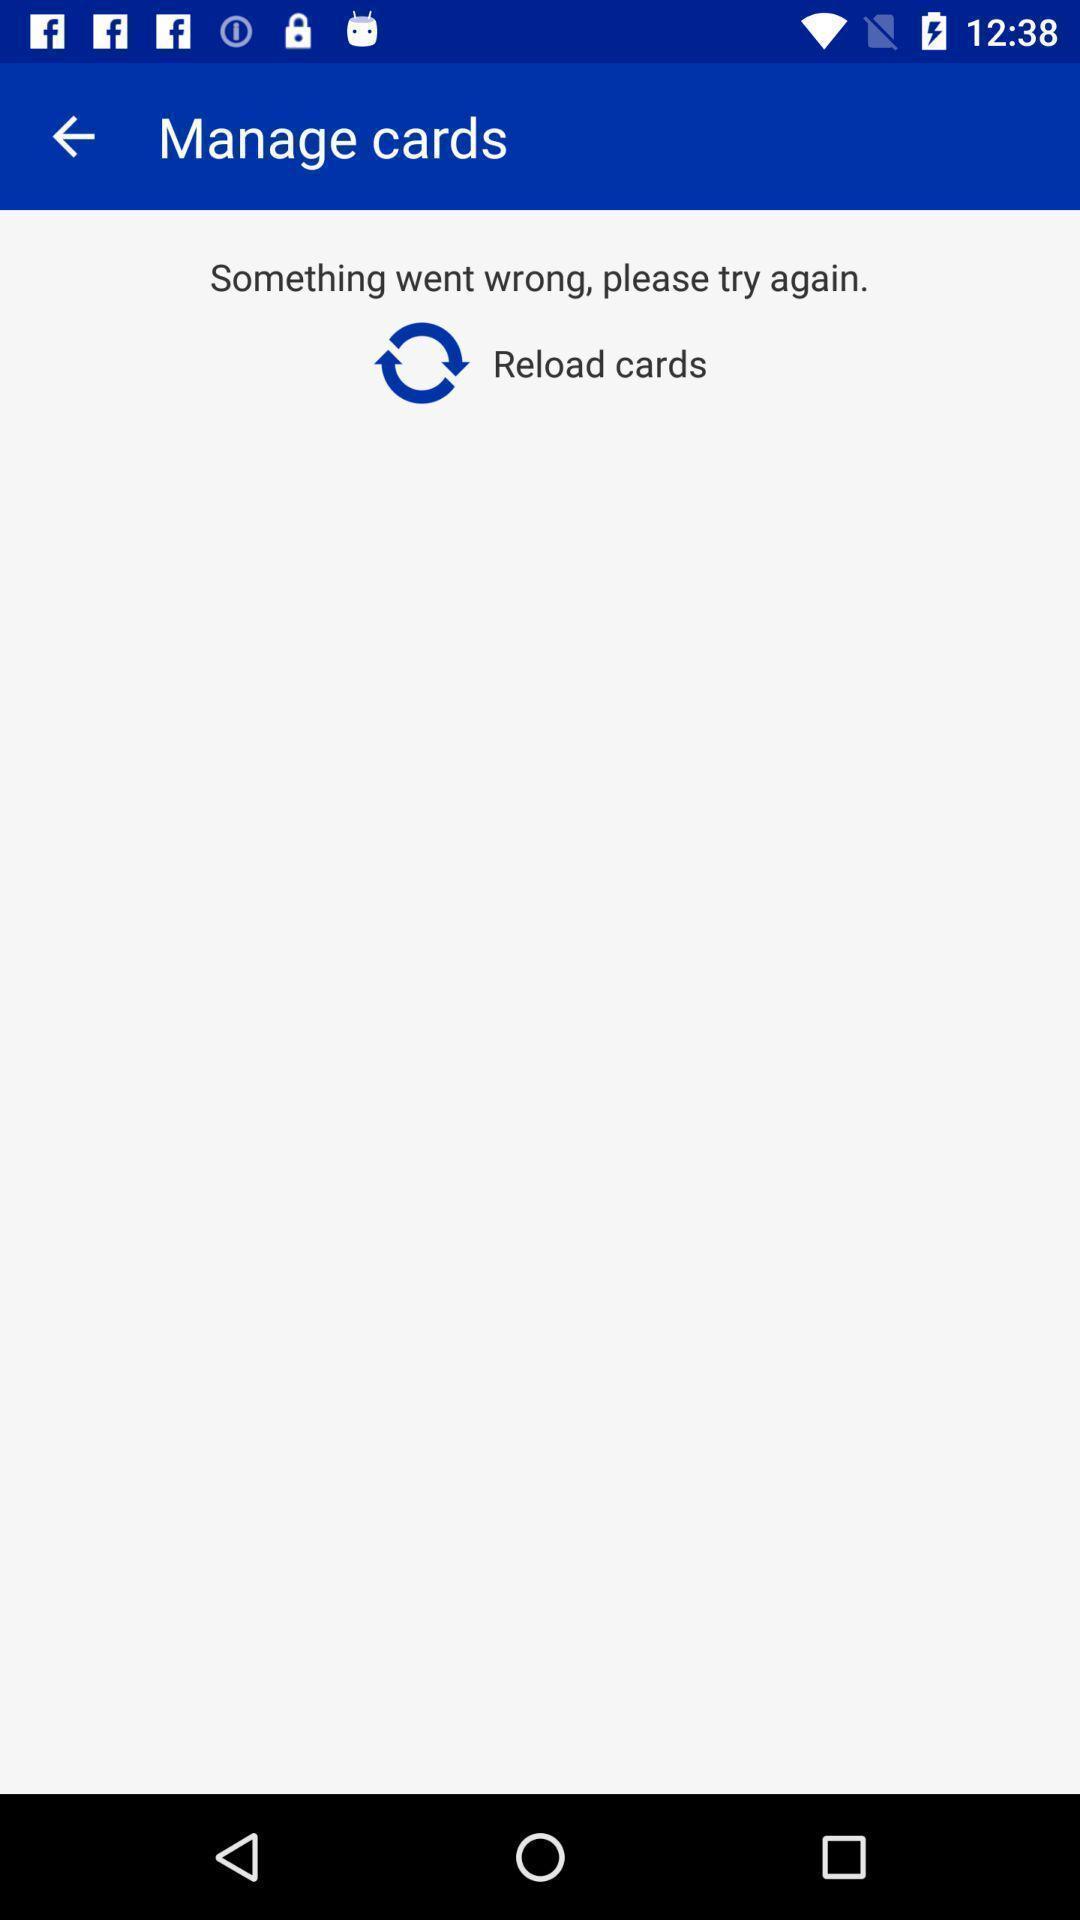Give me a summary of this screen capture. Screen displaying the manage cards page. 